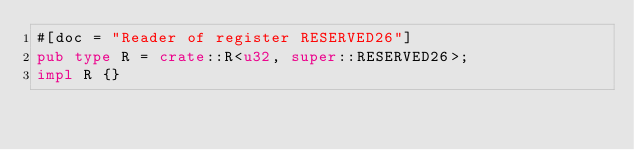Convert code to text. <code><loc_0><loc_0><loc_500><loc_500><_Rust_>#[doc = "Reader of register RESERVED26"]
pub type R = crate::R<u32, super::RESERVED26>;
impl R {}
</code> 